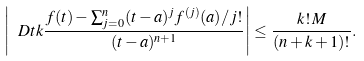<formula> <loc_0><loc_0><loc_500><loc_500>\left | \ D { t } { k } \frac { f ( t ) - \sum _ { j = 0 } ^ { n } ( t - a ) ^ { j } f ^ { ( j ) } ( a ) / j ! } { ( t - a ) ^ { n + 1 } } \right | \leq \frac { k ! \, M } { ( n + k + 1 ) ! } .</formula> 